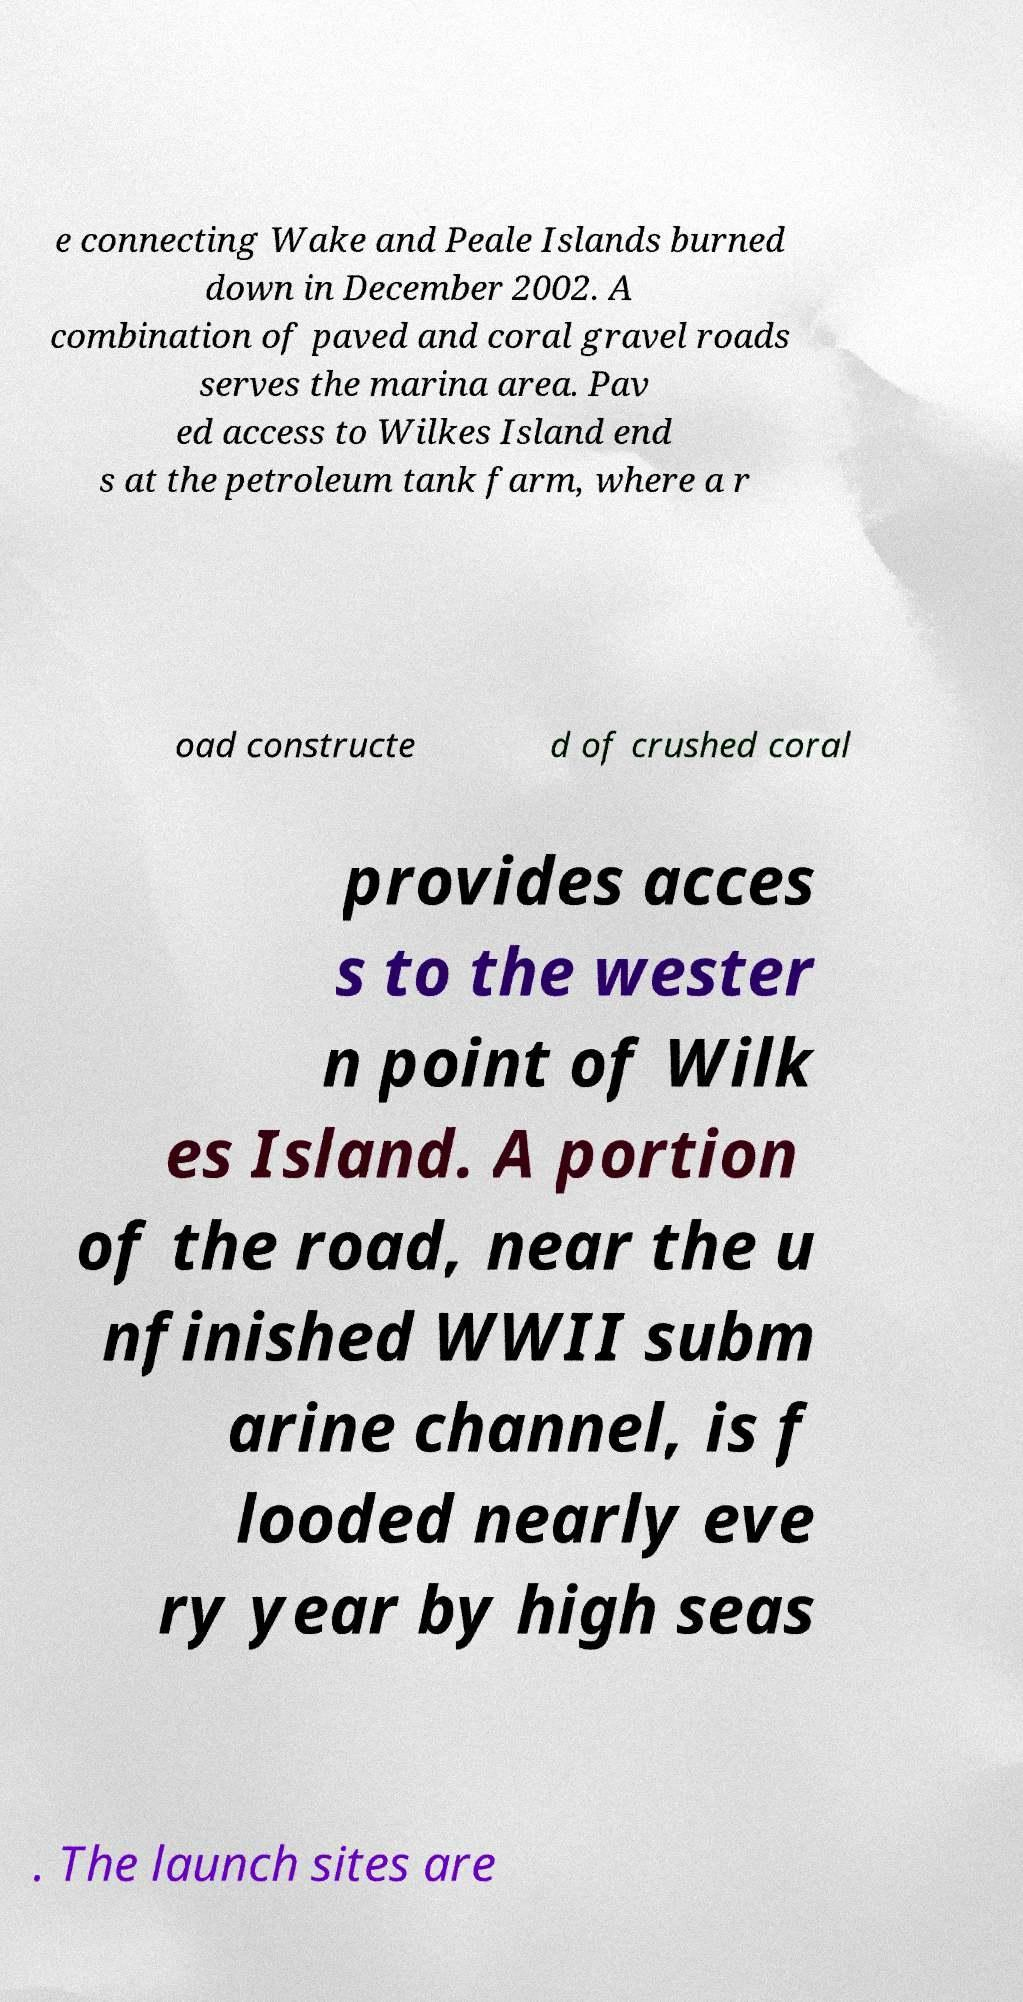For documentation purposes, I need the text within this image transcribed. Could you provide that? e connecting Wake and Peale Islands burned down in December 2002. A combination of paved and coral gravel roads serves the marina area. Pav ed access to Wilkes Island end s at the petroleum tank farm, where a r oad constructe d of crushed coral provides acces s to the wester n point of Wilk es Island. A portion of the road, near the u nfinished WWII subm arine channel, is f looded nearly eve ry year by high seas . The launch sites are 